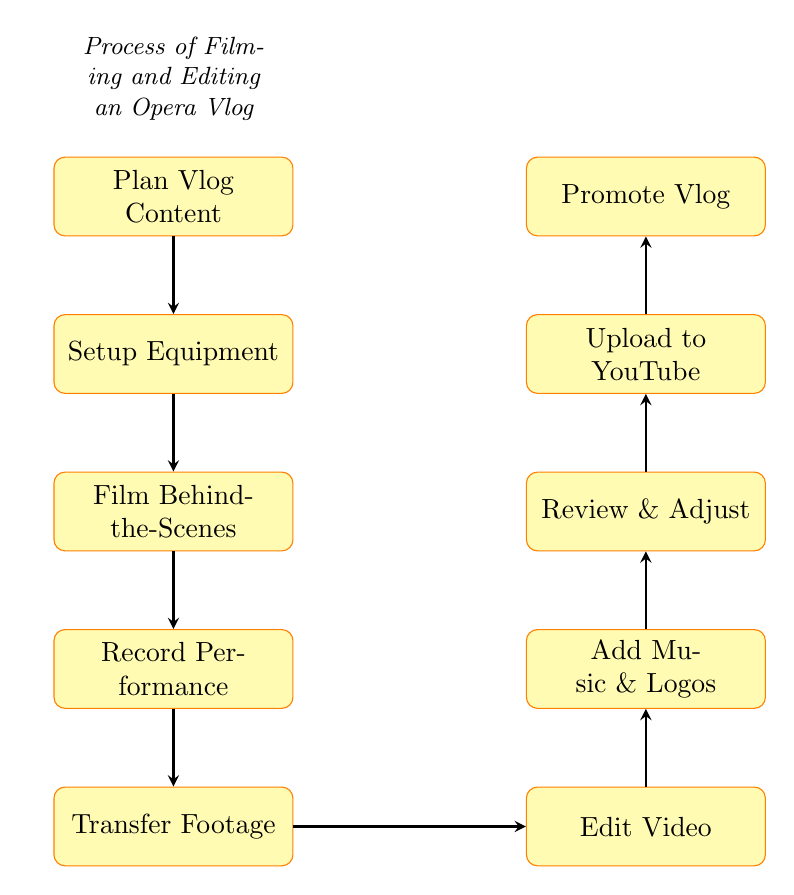What is the first step in the process? The diagram indicates the first step is labeled "Plan Vlog Content", which is the starting point of the flow.
Answer: Plan Vlog Content How many nodes are there in total? By counting the individual steps in the diagram, we find twelve unique nodes including all actions and processes.
Answer: Ten What comes after filming behind-the-scenes? The diagram shows that "Film Behind-the-Scenes" is followed by "Record Performance", indicating the next step in the flow.
Answer: Record Performance Which node is directly before uploading to YouTube? Looking at the flow, "Review & Adjust" is the step directly before "Upload to YouTube", showing the sequence.
Answer: Review & Adjust What two steps directly follow editing the video? The diagram outlines that after "Edit Video", the next two steps are "Add Music & Logos" and then "Review & Adjust", representing the sequence of actions.
Answer: Add Music & Logos, Review & Adjust What is the last step in the process? The flow chart concludes with "Promote Vlog" as the final action, making it the last step in the process.
Answer: Promote Vlog What is involved in the "Setup Equipment" step? The description for "Setup Equipment" provides details about arranging cameras, microphones, and lighting at the opera venue, outlining what this step consists of.
Answer: Arrange cameras, microphones, lighting Which node is related to transferring video files? The node titled "Transfer Footage" is specifically related to moving video files from the camera to the computer.
Answer: Transfer Footage How many steps are there between recording performance and promoting the vlog? By looking at the flow, we can identify three steps: "Transfer Footage", "Edit Video", and "Upload to YouTube", which occur between these two nodes.
Answer: Three Which step occurs immediately after transferring footage? Upon reviewing the flowchart, "Edit Video" is the immediate next step following "Transfer Footage", indicating its sequential position.
Answer: Edit Video 